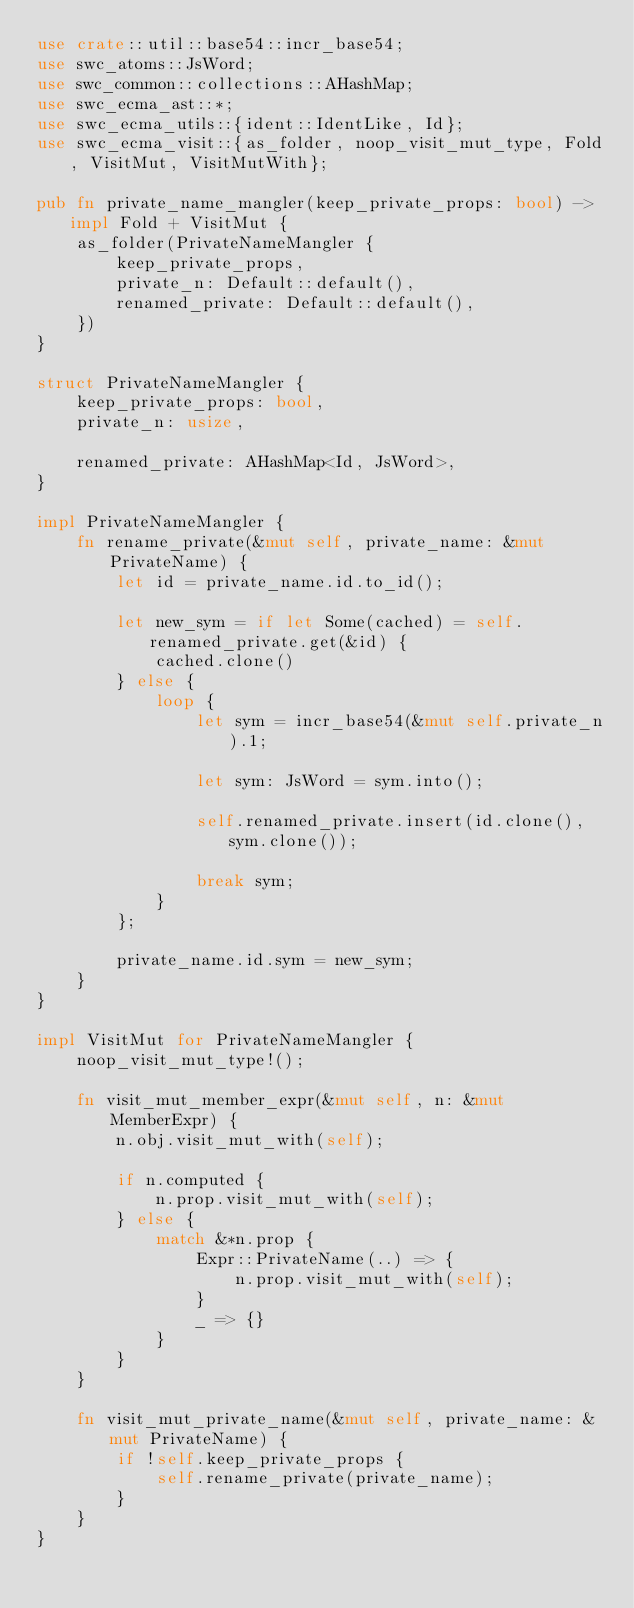<code> <loc_0><loc_0><loc_500><loc_500><_Rust_>use crate::util::base54::incr_base54;
use swc_atoms::JsWord;
use swc_common::collections::AHashMap;
use swc_ecma_ast::*;
use swc_ecma_utils::{ident::IdentLike, Id};
use swc_ecma_visit::{as_folder, noop_visit_mut_type, Fold, VisitMut, VisitMutWith};

pub fn private_name_mangler(keep_private_props: bool) -> impl Fold + VisitMut {
    as_folder(PrivateNameMangler {
        keep_private_props,
        private_n: Default::default(),
        renamed_private: Default::default(),
    })
}

struct PrivateNameMangler {
    keep_private_props: bool,
    private_n: usize,

    renamed_private: AHashMap<Id, JsWord>,
}

impl PrivateNameMangler {
    fn rename_private(&mut self, private_name: &mut PrivateName) {
        let id = private_name.id.to_id();

        let new_sym = if let Some(cached) = self.renamed_private.get(&id) {
            cached.clone()
        } else {
            loop {
                let sym = incr_base54(&mut self.private_n).1;

                let sym: JsWord = sym.into();

                self.renamed_private.insert(id.clone(), sym.clone());

                break sym;
            }
        };

        private_name.id.sym = new_sym;
    }
}

impl VisitMut for PrivateNameMangler {
    noop_visit_mut_type!();

    fn visit_mut_member_expr(&mut self, n: &mut MemberExpr) {
        n.obj.visit_mut_with(self);

        if n.computed {
            n.prop.visit_mut_with(self);
        } else {
            match &*n.prop {
                Expr::PrivateName(..) => {
                    n.prop.visit_mut_with(self);
                }
                _ => {}
            }
        }
    }

    fn visit_mut_private_name(&mut self, private_name: &mut PrivateName) {
        if !self.keep_private_props {
            self.rename_private(private_name);
        }
    }
}
</code> 